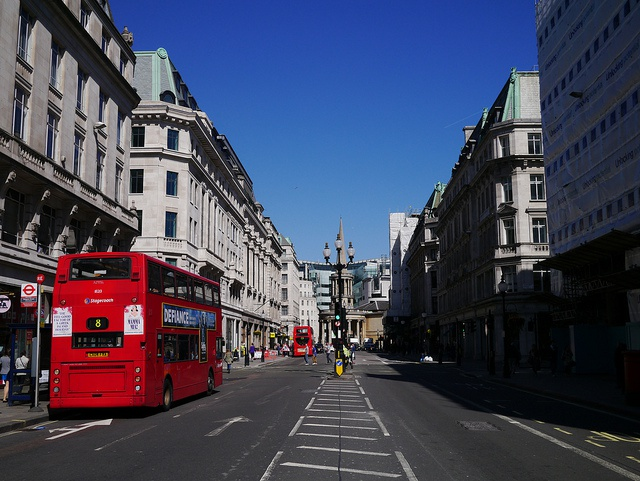Describe the objects in this image and their specific colors. I can see bus in gray, brown, black, and maroon tones, bus in gray, black, brown, and maroon tones, people in gray and black tones, people in gray, darkgray, and black tones, and traffic light in gray, black, maroon, and brown tones in this image. 